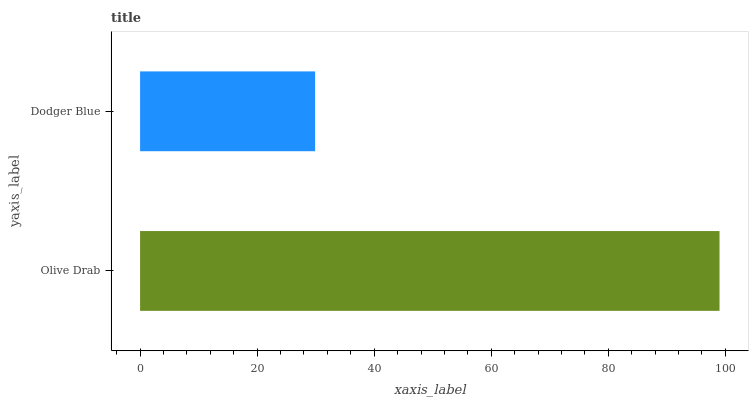Is Dodger Blue the minimum?
Answer yes or no. Yes. Is Olive Drab the maximum?
Answer yes or no. Yes. Is Dodger Blue the maximum?
Answer yes or no. No. Is Olive Drab greater than Dodger Blue?
Answer yes or no. Yes. Is Dodger Blue less than Olive Drab?
Answer yes or no. Yes. Is Dodger Blue greater than Olive Drab?
Answer yes or no. No. Is Olive Drab less than Dodger Blue?
Answer yes or no. No. Is Olive Drab the high median?
Answer yes or no. Yes. Is Dodger Blue the low median?
Answer yes or no. Yes. Is Dodger Blue the high median?
Answer yes or no. No. Is Olive Drab the low median?
Answer yes or no. No. 